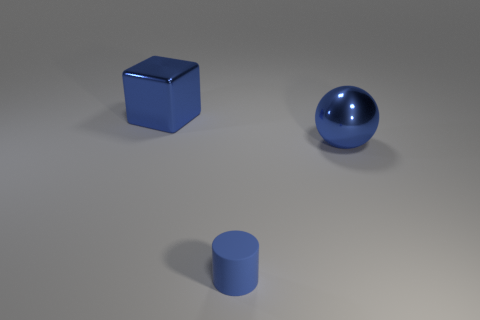Subtract 1 balls. How many balls are left? 0 Subtract all purple blocks. Subtract all gray balls. How many blocks are left? 1 Subtract all blue rubber cylinders. Subtract all blue balls. How many objects are left? 1 Add 1 large things. How many large things are left? 3 Add 2 cyan things. How many cyan things exist? 2 Add 2 blocks. How many objects exist? 5 Subtract 0 yellow blocks. How many objects are left? 3 Subtract all balls. How many objects are left? 2 